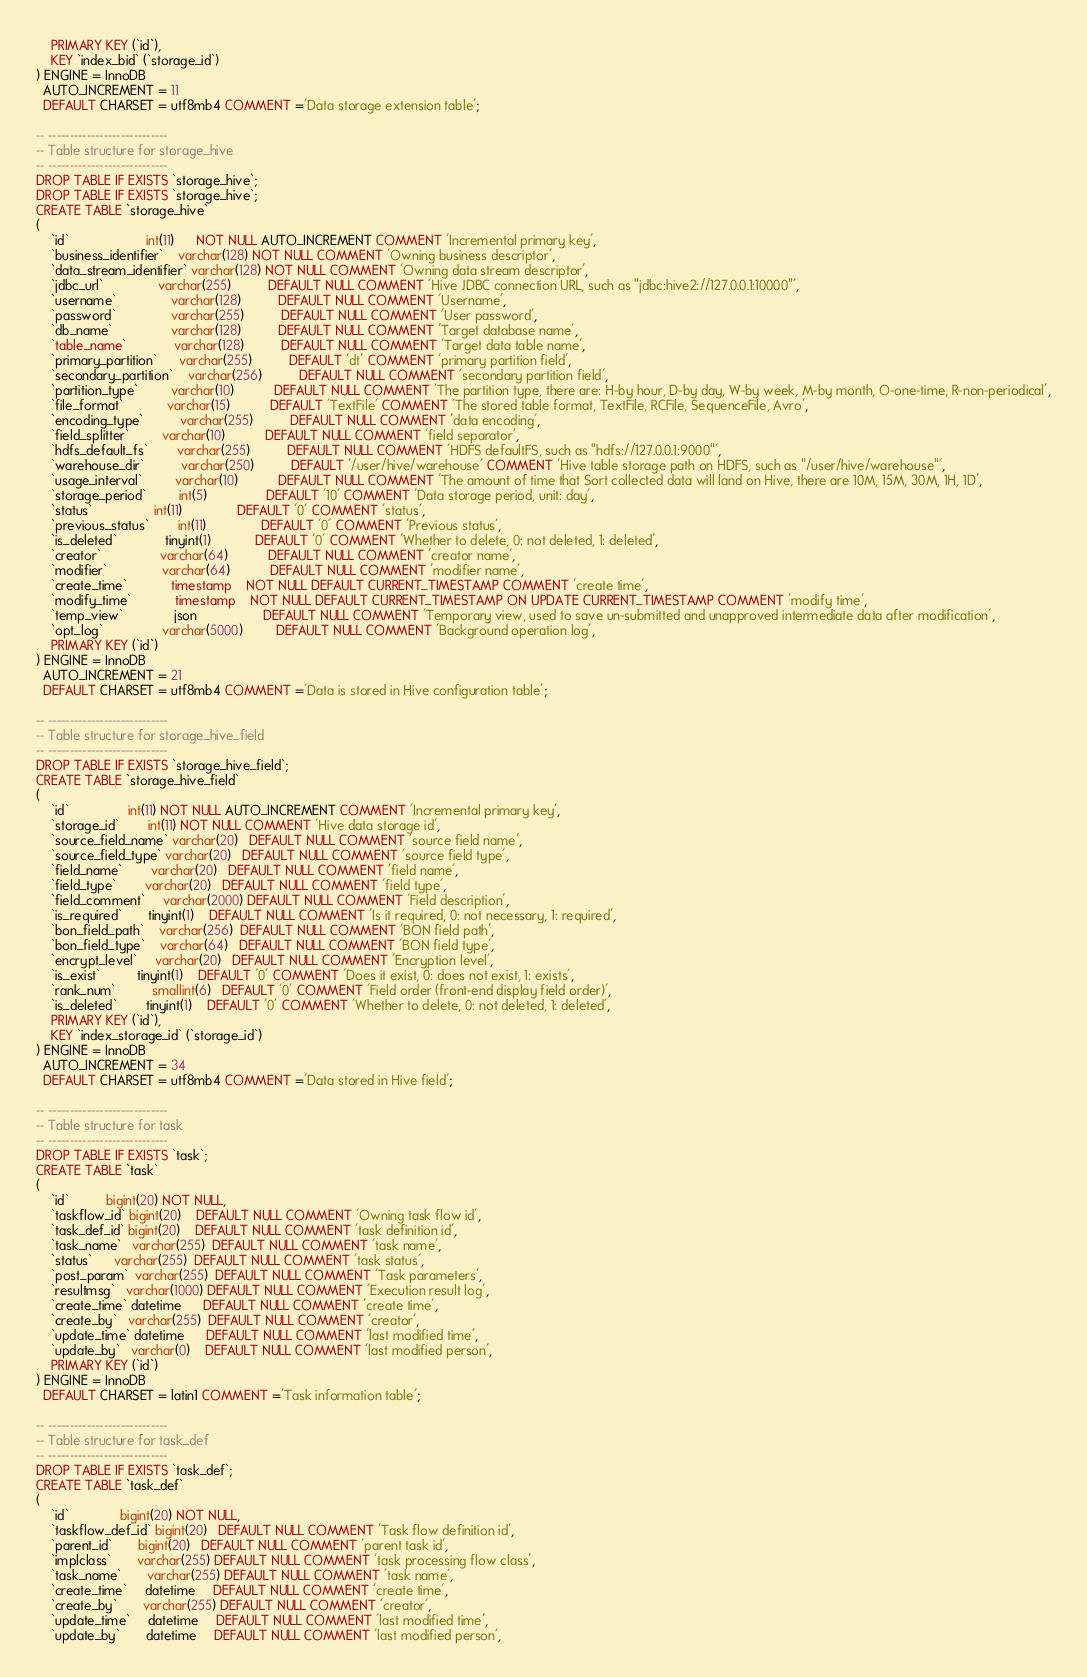<code> <loc_0><loc_0><loc_500><loc_500><_SQL_>    PRIMARY KEY (`id`),
    KEY `index_bid` (`storage_id`)
) ENGINE = InnoDB
  AUTO_INCREMENT = 11
  DEFAULT CHARSET = utf8mb4 COMMENT ='Data storage extension table';

-- ----------------------------
-- Table structure for storage_hive
-- ----------------------------
DROP TABLE IF EXISTS `storage_hive`;
DROP TABLE IF EXISTS `storage_hive`;
CREATE TABLE `storage_hive`
(
    `id`                     int(11)      NOT NULL AUTO_INCREMENT COMMENT 'Incremental primary key',
    `business_identifier`    varchar(128) NOT NULL COMMENT 'Owning business descriptor',
    `data_stream_identifier` varchar(128) NOT NULL COMMENT 'Owning data stream descriptor',
    `jdbc_url`               varchar(255)          DEFAULT NULL COMMENT 'Hive JDBC connection URL, such as "jdbc:hive2://127.0.0.1:10000"',
    `username`               varchar(128)          DEFAULT NULL COMMENT 'Username',
    `password`               varchar(255)          DEFAULT NULL COMMENT 'User password',
    `db_name`                varchar(128)          DEFAULT NULL COMMENT 'Target database name',
    `table_name`             varchar(128)          DEFAULT NULL COMMENT 'Target data table name',
    `primary_partition`      varchar(255)          DEFAULT 'dt' COMMENT 'primary partition field',
    `secondary_partition`    varchar(256)          DEFAULT NULL COMMENT 'secondary partition field',
    `partition_type`         varchar(10)           DEFAULT NULL COMMENT 'The partition type, there are: H-by hour, D-by day, W-by week, M-by month, O-one-time, R-non-periodical',
    `file_format`            varchar(15)           DEFAULT 'TextFile' COMMENT 'The stored table format, TextFile, RCFile, SequenceFile, Avro',
    `encoding_type`          varchar(255)          DEFAULT NULL COMMENT 'data encoding',
    `field_splitter`         varchar(10)           DEFAULT NULL COMMENT 'field separator',
    `hdfs_default_fs`        varchar(255)          DEFAULT NULL COMMENT 'HDFS defaultFS, such as "hdfs://127.0.0.1:9000"',
    `warehouse_dir`          varchar(250)          DEFAULT '/user/hive/warehouse' COMMENT 'Hive table storage path on HDFS, such as "/user/hive/warehouse"',
    `usage_interval`         varchar(10)           DEFAULT NULL COMMENT 'The amount of time that Sort collected data will land on Hive, there are 10M, 15M, 30M, 1H, 1D',
    `storage_period`         int(5)                DEFAULT '10' COMMENT 'Data storage period, unit: day',
    `status`                 int(11)               DEFAULT '0' COMMENT 'status',
    `previous_status`        int(11)               DEFAULT '0' COMMENT 'Previous status',
    `is_deleted`             tinyint(1)            DEFAULT '0' COMMENT 'Whether to delete, 0: not deleted, 1: deleted',
    `creator`                varchar(64)           DEFAULT NULL COMMENT 'creator name',
    `modifier`               varchar(64)           DEFAULT NULL COMMENT 'modifier name',
    `create_time`            timestamp    NOT NULL DEFAULT CURRENT_TIMESTAMP COMMENT 'create time',
    `modify_time`            timestamp    NOT NULL DEFAULT CURRENT_TIMESTAMP ON UPDATE CURRENT_TIMESTAMP COMMENT 'modify time',
    `temp_view`              json                  DEFAULT NULL COMMENT 'Temporary view, used to save un-submitted and unapproved intermediate data after modification',
    `opt_log`                varchar(5000)         DEFAULT NULL COMMENT 'Background operation log',
    PRIMARY KEY (`id`)
) ENGINE = InnoDB
  AUTO_INCREMENT = 21
  DEFAULT CHARSET = utf8mb4 COMMENT ='Data is stored in Hive configuration table';

-- ----------------------------
-- Table structure for storage_hive_field
-- ----------------------------
DROP TABLE IF EXISTS `storage_hive_field`;
CREATE TABLE `storage_hive_field`
(
    `id`                int(11) NOT NULL AUTO_INCREMENT COMMENT 'Incremental primary key',
    `storage_id`        int(11) NOT NULL COMMENT 'Hive data storage id',
    `source_field_name` varchar(20)   DEFAULT NULL COMMENT 'source field name',
    `source_field_type` varchar(20)   DEFAULT NULL COMMENT 'source field type',
    `field_name`        varchar(20)   DEFAULT NULL COMMENT 'field name',
    `field_type`        varchar(20)   DEFAULT NULL COMMENT 'field type',
    `field_comment`     varchar(2000) DEFAULT NULL COMMENT 'Field description',
    `is_required`       tinyint(1)    DEFAULT NULL COMMENT 'Is it required, 0: not necessary, 1: required',
    `bon_field_path`    varchar(256)  DEFAULT NULL COMMENT 'BON field path',
    `bon_field_type`    varchar(64)   DEFAULT NULL COMMENT 'BON field type',
    `encrypt_level`     varchar(20)   DEFAULT NULL COMMENT 'Encryption level',
    `is_exist`          tinyint(1)    DEFAULT '0' COMMENT 'Does it exist, 0: does not exist, 1: exists',
    `rank_num`          smallint(6)   DEFAULT '0' COMMENT 'Field order (front-end display field order)',
    `is_deleted`        tinyint(1)    DEFAULT '0' COMMENT 'Whether to delete, 0: not deleted, 1: deleted',
    PRIMARY KEY (`id`),
    KEY `index_storage_id` (`storage_id`)
) ENGINE = InnoDB
  AUTO_INCREMENT = 34
  DEFAULT CHARSET = utf8mb4 COMMENT ='Data stored in Hive field';

-- ----------------------------
-- Table structure for task
-- ----------------------------
DROP TABLE IF EXISTS `task`;
CREATE TABLE `task`
(
    `id`          bigint(20) NOT NULL,
    `taskflow_id` bigint(20)    DEFAULT NULL COMMENT 'Owning task flow id',
    `task_def_id` bigint(20)    DEFAULT NULL COMMENT 'task definition id',
    `task_name`   varchar(255)  DEFAULT NULL COMMENT 'task name',
    `status`      varchar(255)  DEFAULT NULL COMMENT 'task status',
    `post_param`  varchar(255)  DEFAULT NULL COMMENT 'Task parameters',
    `resultmsg`   varchar(1000) DEFAULT NULL COMMENT 'Execution result log',
    `create_time` datetime      DEFAULT NULL COMMENT 'create time',
    `create_by`   varchar(255)  DEFAULT NULL COMMENT 'creator',
    `update_time` datetime      DEFAULT NULL COMMENT 'last modified time',
    `update_by`   varchar(0)    DEFAULT NULL COMMENT 'last modified person',
    PRIMARY KEY (`id`)
) ENGINE = InnoDB
  DEFAULT CHARSET = latin1 COMMENT ='Task information table';

-- ----------------------------
-- Table structure for task_def
-- ----------------------------
DROP TABLE IF EXISTS `task_def`;
CREATE TABLE `task_def`
(
    `id`              bigint(20) NOT NULL,
    `taskflow_def_id` bigint(20)   DEFAULT NULL COMMENT 'Task flow definition id',
    `parent_id`       bigint(20)   DEFAULT NULL COMMENT 'parent task id',
    `implclass`       varchar(255) DEFAULT NULL COMMENT 'task processing flow class',
    `task_name`       varchar(255) DEFAULT NULL COMMENT 'task name',
    `create_time`     datetime     DEFAULT NULL COMMENT 'create time',
    `create_by`       varchar(255) DEFAULT NULL COMMENT 'creator',
    `update_time`     datetime     DEFAULT NULL COMMENT 'last modified time',
    `update_by`       datetime     DEFAULT NULL COMMENT 'last modified person',</code> 